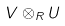Convert formula to latex. <formula><loc_0><loc_0><loc_500><loc_500>V \otimes _ { R } U</formula> 